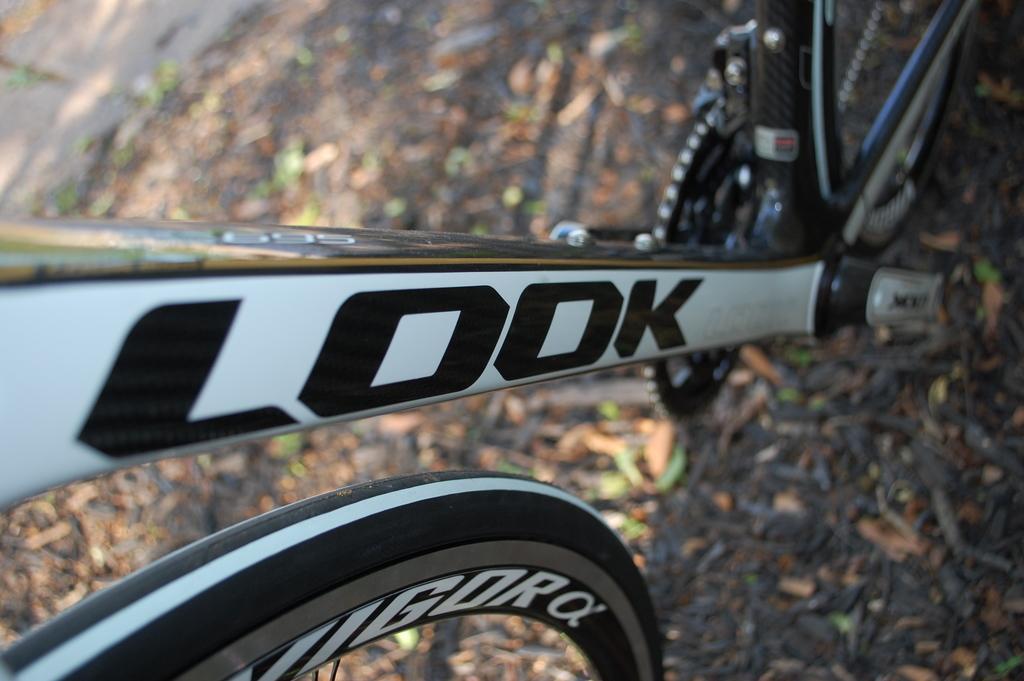Could you give a brief overview of what you see in this image? In the center of the image we can see a cycle with some text on it. In the background, we can see it is blurred. 